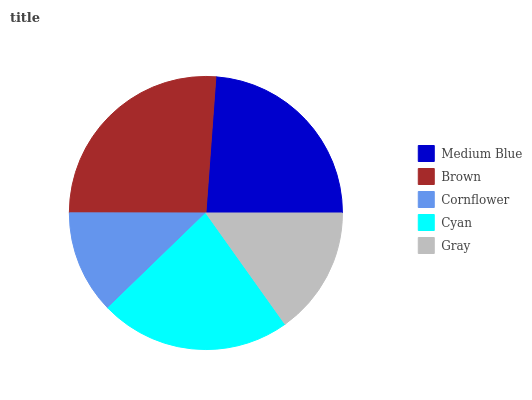Is Cornflower the minimum?
Answer yes or no. Yes. Is Brown the maximum?
Answer yes or no. Yes. Is Brown the minimum?
Answer yes or no. No. Is Cornflower the maximum?
Answer yes or no. No. Is Brown greater than Cornflower?
Answer yes or no. Yes. Is Cornflower less than Brown?
Answer yes or no. Yes. Is Cornflower greater than Brown?
Answer yes or no. No. Is Brown less than Cornflower?
Answer yes or no. No. Is Cyan the high median?
Answer yes or no. Yes. Is Cyan the low median?
Answer yes or no. Yes. Is Gray the high median?
Answer yes or no. No. Is Medium Blue the low median?
Answer yes or no. No. 